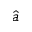<formula> <loc_0><loc_0><loc_500><loc_500>\hat { a }</formula> 